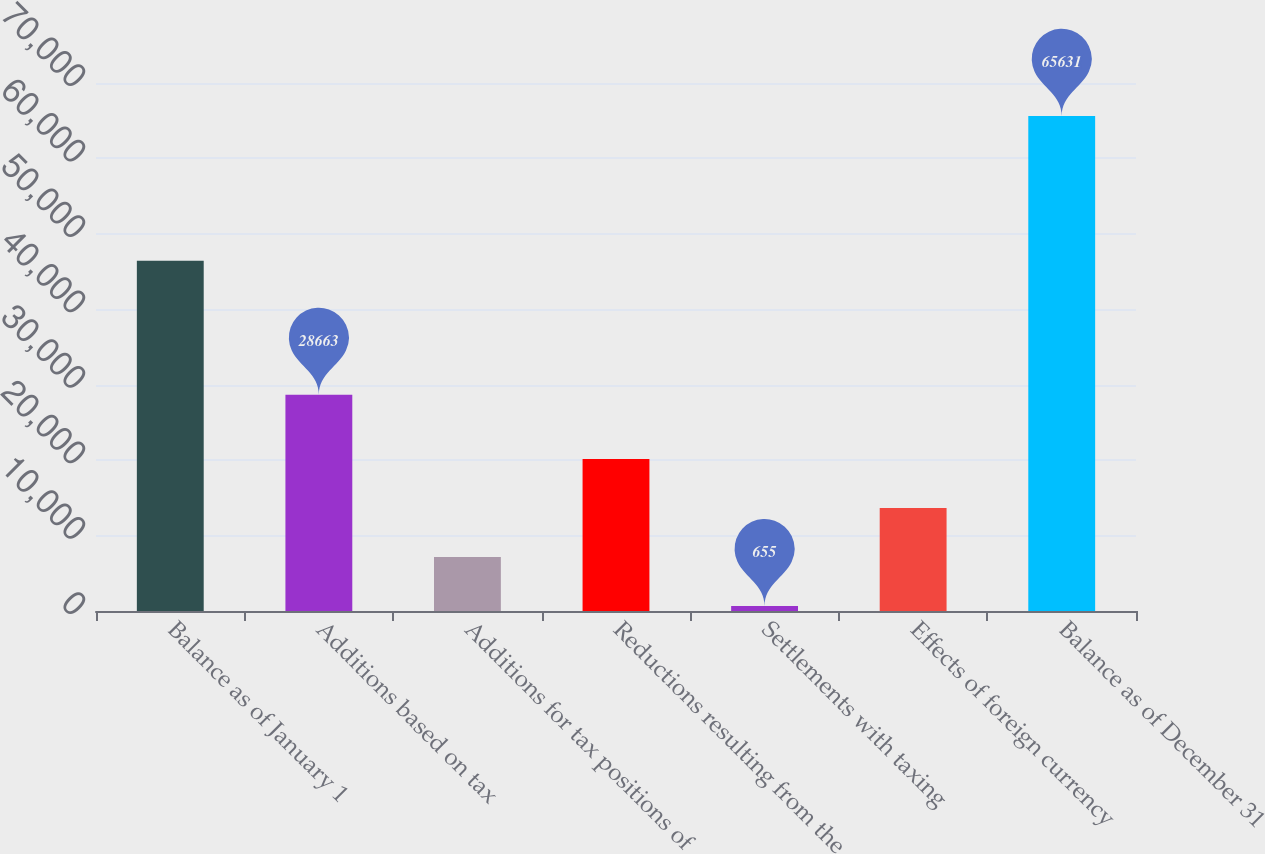Convert chart. <chart><loc_0><loc_0><loc_500><loc_500><bar_chart><fcel>Balance as of January 1<fcel>Additions based on tax<fcel>Additions for tax positions of<fcel>Reductions resulting from the<fcel>Settlements with taxing<fcel>Effects of foreign currency<fcel>Balance as of December 31<nl><fcel>46434<fcel>28663<fcel>7152.6<fcel>20147.8<fcel>655<fcel>13650.2<fcel>65631<nl></chart> 